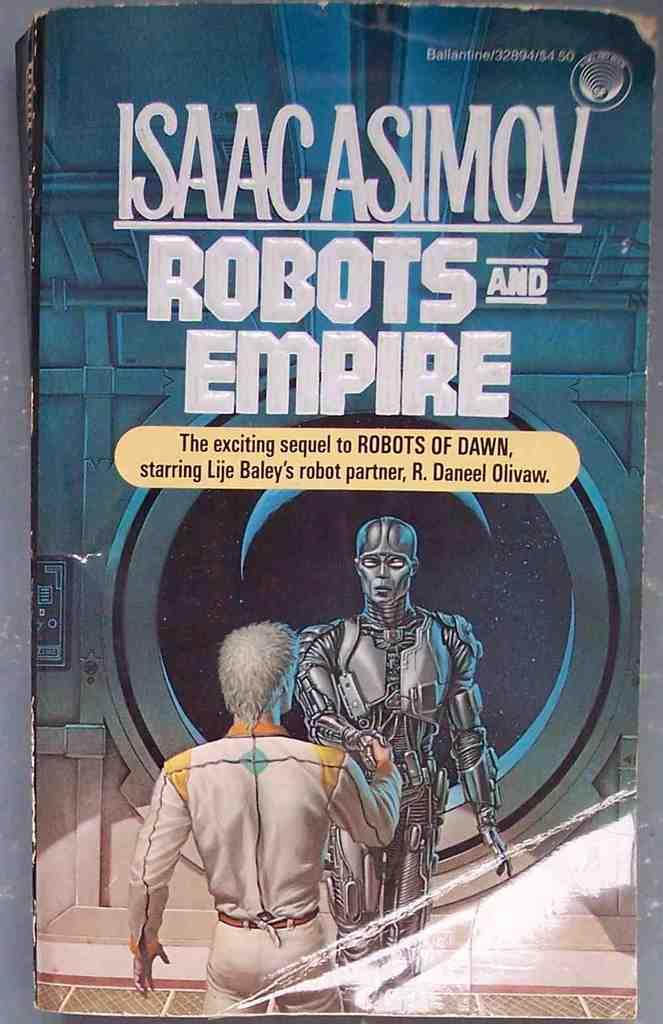<image>
Offer a succinct explanation of the picture presented. A robot meets an astronaut on the cover of an Isaac Asimov science fiction novel. 